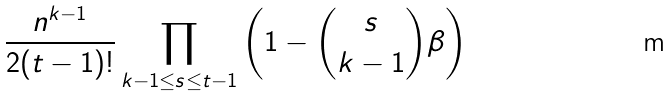Convert formula to latex. <formula><loc_0><loc_0><loc_500><loc_500>\frac { n ^ { k - 1 } } { 2 ( t - 1 ) ! } \prod _ { k - 1 \leq s \leq t - 1 } \left ( 1 - \binom { s } { k - 1 } \beta \right )</formula> 